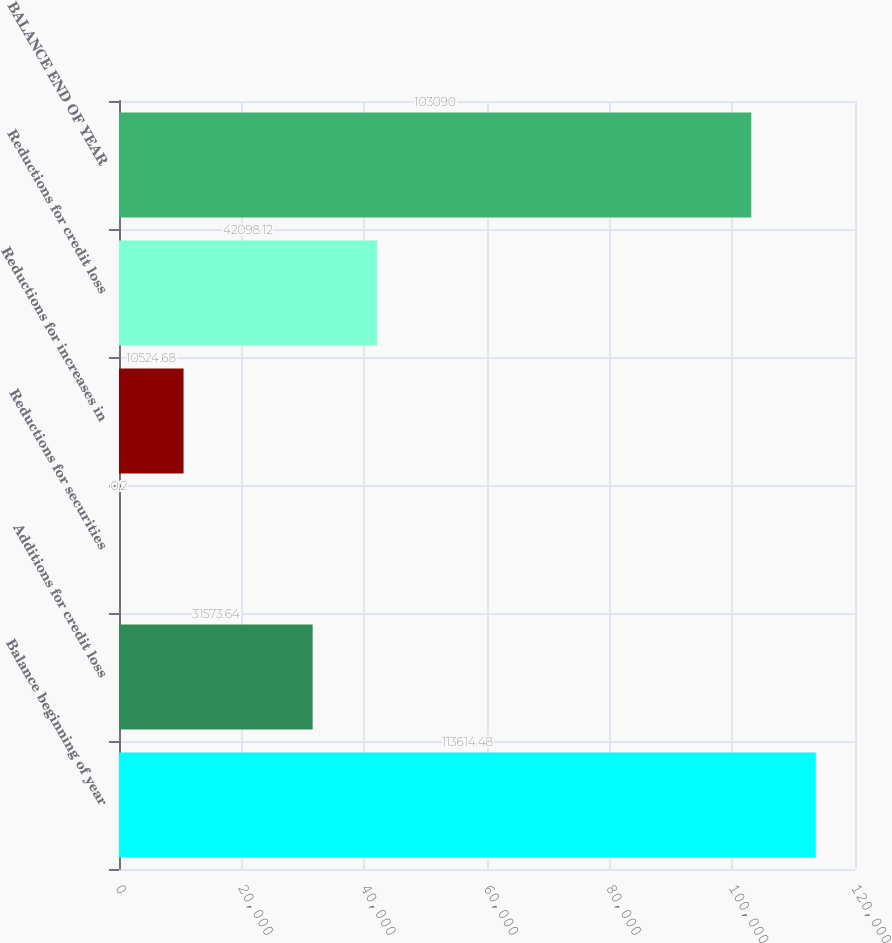<chart> <loc_0><loc_0><loc_500><loc_500><bar_chart><fcel>Balance beginning of year<fcel>Additions for credit loss<fcel>Reductions for securities<fcel>Reductions for increases in<fcel>Reductions for credit loss<fcel>BALANCE END OF YEAR<nl><fcel>113614<fcel>31573.6<fcel>0.2<fcel>10524.7<fcel>42098.1<fcel>103090<nl></chart> 